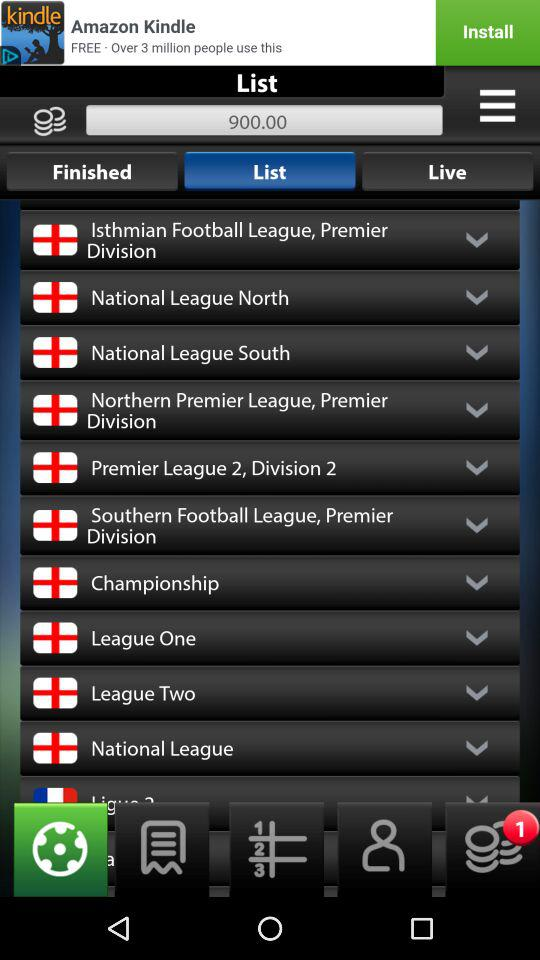Who is on the "Finished" list?
When the provided information is insufficient, respond with <no answer>. <no answer> 